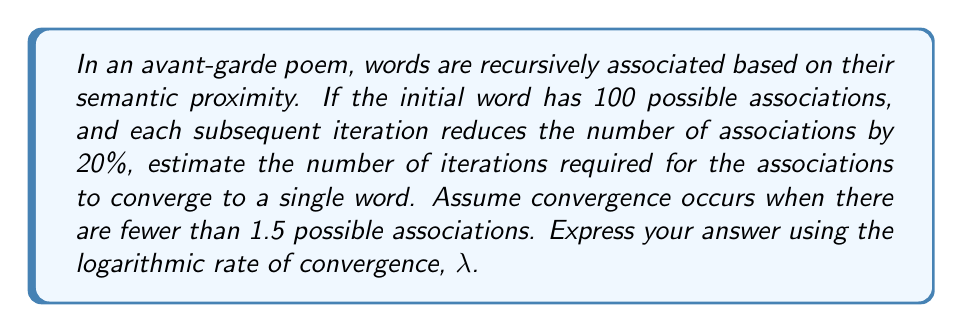Can you solve this math problem? Let's approach this step-by-step:

1) Let $a_n$ be the number of associations at the $n$-th iteration.
   Initial condition: $a_0 = 100$

2) Each iteration reduces associations by 20%, so the recursive relation is:
   $a_{n+1} = 0.8a_n$

3) We can express this as: $a_n = 100 * (0.8)^n$

4) Convergence occurs when $a_n < 1.5$

5) So, we need to solve: $100 * (0.8)^n < 1.5$

6) Taking logarithms of both sides:
   $\ln(100) + n\ln(0.8) < \ln(1.5)$

7) Solving for $n$:
   $n > \frac{\ln(1.5) - \ln(100)}{\ln(0.8)} \approx 13.22$

8) The smallest integer $n$ satisfying this is 14.

9) The rate of convergence $\lambda$ is given by:
   $\lambda = -\ln(0.8) \approx 0.223$

10) This means each iteration reduces the error by a factor of $e^{-0.223} \approx 0.8$, which aligns with our 20% reduction per iteration.
Answer: $\lambda \approx 0.223$ 